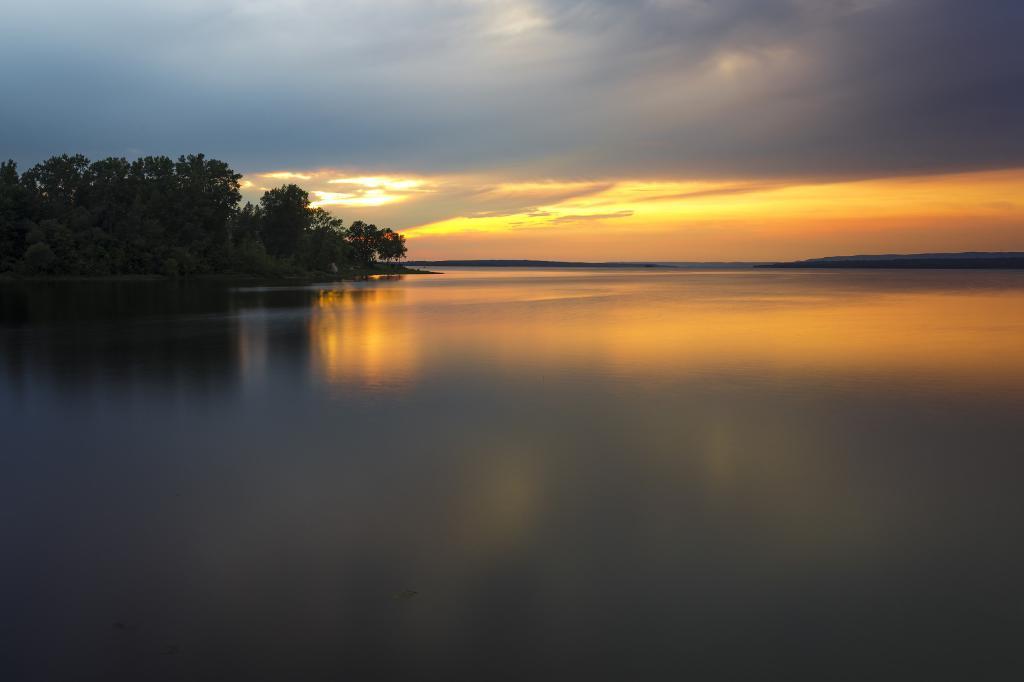How would you summarize this image in a sentence or two? In this picture we can see trees, water and in the background we can see the sky with clouds. 